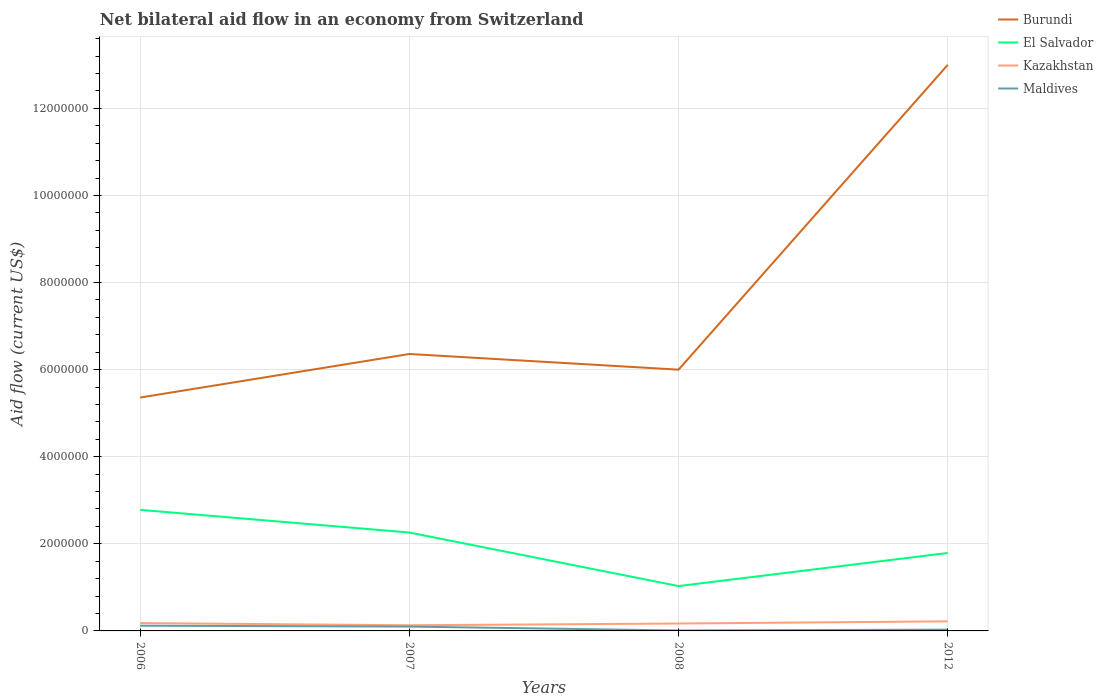How many different coloured lines are there?
Make the answer very short. 4. Does the line corresponding to Kazakhstan intersect with the line corresponding to El Salvador?
Keep it short and to the point. No. Across all years, what is the maximum net bilateral aid flow in El Salvador?
Ensure brevity in your answer.  1.03e+06. In which year was the net bilateral aid flow in Maldives maximum?
Your answer should be very brief. 2008. What is the total net bilateral aid flow in Maldives in the graph?
Offer a terse response. 2.00e+04. What is the difference between the highest and the second highest net bilateral aid flow in Burundi?
Provide a succinct answer. 7.64e+06. How many lines are there?
Make the answer very short. 4. What is the difference between two consecutive major ticks on the Y-axis?
Provide a short and direct response. 2.00e+06. Does the graph contain any zero values?
Your answer should be very brief. No. Where does the legend appear in the graph?
Your response must be concise. Top right. How many legend labels are there?
Offer a terse response. 4. How are the legend labels stacked?
Keep it short and to the point. Vertical. What is the title of the graph?
Give a very brief answer. Net bilateral aid flow in an economy from Switzerland. Does "Lower middle income" appear as one of the legend labels in the graph?
Your answer should be compact. No. What is the Aid flow (current US$) in Burundi in 2006?
Offer a terse response. 5.36e+06. What is the Aid flow (current US$) in El Salvador in 2006?
Give a very brief answer. 2.78e+06. What is the Aid flow (current US$) in Maldives in 2006?
Your response must be concise. 1.20e+05. What is the Aid flow (current US$) of Burundi in 2007?
Offer a terse response. 6.36e+06. What is the Aid flow (current US$) of El Salvador in 2007?
Offer a very short reply. 2.26e+06. What is the Aid flow (current US$) in Kazakhstan in 2007?
Keep it short and to the point. 1.30e+05. What is the Aid flow (current US$) of Maldives in 2007?
Your answer should be compact. 1.00e+05. What is the Aid flow (current US$) of Burundi in 2008?
Offer a very short reply. 6.00e+06. What is the Aid flow (current US$) in El Salvador in 2008?
Make the answer very short. 1.03e+06. What is the Aid flow (current US$) of Kazakhstan in 2008?
Provide a short and direct response. 1.70e+05. What is the Aid flow (current US$) in Burundi in 2012?
Ensure brevity in your answer.  1.30e+07. What is the Aid flow (current US$) of El Salvador in 2012?
Keep it short and to the point. 1.79e+06. What is the Aid flow (current US$) of Kazakhstan in 2012?
Your answer should be very brief. 2.20e+05. What is the Aid flow (current US$) of Maldives in 2012?
Provide a succinct answer. 3.00e+04. Across all years, what is the maximum Aid flow (current US$) of Burundi?
Ensure brevity in your answer.  1.30e+07. Across all years, what is the maximum Aid flow (current US$) of El Salvador?
Offer a very short reply. 2.78e+06. Across all years, what is the maximum Aid flow (current US$) in Kazakhstan?
Offer a terse response. 2.20e+05. Across all years, what is the minimum Aid flow (current US$) of Burundi?
Offer a terse response. 5.36e+06. Across all years, what is the minimum Aid flow (current US$) of El Salvador?
Make the answer very short. 1.03e+06. Across all years, what is the minimum Aid flow (current US$) of Kazakhstan?
Offer a terse response. 1.30e+05. Across all years, what is the minimum Aid flow (current US$) of Maldives?
Your answer should be very brief. 10000. What is the total Aid flow (current US$) of Burundi in the graph?
Make the answer very short. 3.07e+07. What is the total Aid flow (current US$) in El Salvador in the graph?
Keep it short and to the point. 7.86e+06. What is the total Aid flow (current US$) of Kazakhstan in the graph?
Your answer should be very brief. 7.00e+05. What is the difference between the Aid flow (current US$) in Burundi in 2006 and that in 2007?
Provide a short and direct response. -1.00e+06. What is the difference between the Aid flow (current US$) in El Salvador in 2006 and that in 2007?
Make the answer very short. 5.20e+05. What is the difference between the Aid flow (current US$) of Kazakhstan in 2006 and that in 2007?
Ensure brevity in your answer.  5.00e+04. What is the difference between the Aid flow (current US$) of Maldives in 2006 and that in 2007?
Keep it short and to the point. 2.00e+04. What is the difference between the Aid flow (current US$) of Burundi in 2006 and that in 2008?
Your answer should be very brief. -6.40e+05. What is the difference between the Aid flow (current US$) of El Salvador in 2006 and that in 2008?
Offer a very short reply. 1.75e+06. What is the difference between the Aid flow (current US$) in Kazakhstan in 2006 and that in 2008?
Your answer should be compact. 10000. What is the difference between the Aid flow (current US$) of Burundi in 2006 and that in 2012?
Offer a terse response. -7.64e+06. What is the difference between the Aid flow (current US$) in El Salvador in 2006 and that in 2012?
Your answer should be very brief. 9.90e+05. What is the difference between the Aid flow (current US$) in Kazakhstan in 2006 and that in 2012?
Keep it short and to the point. -4.00e+04. What is the difference between the Aid flow (current US$) of Burundi in 2007 and that in 2008?
Offer a terse response. 3.60e+05. What is the difference between the Aid flow (current US$) in El Salvador in 2007 and that in 2008?
Provide a succinct answer. 1.23e+06. What is the difference between the Aid flow (current US$) of Kazakhstan in 2007 and that in 2008?
Offer a terse response. -4.00e+04. What is the difference between the Aid flow (current US$) of Burundi in 2007 and that in 2012?
Keep it short and to the point. -6.64e+06. What is the difference between the Aid flow (current US$) of Maldives in 2007 and that in 2012?
Provide a succinct answer. 7.00e+04. What is the difference between the Aid flow (current US$) in Burundi in 2008 and that in 2012?
Offer a terse response. -7.00e+06. What is the difference between the Aid flow (current US$) in El Salvador in 2008 and that in 2012?
Your response must be concise. -7.60e+05. What is the difference between the Aid flow (current US$) of Kazakhstan in 2008 and that in 2012?
Your answer should be compact. -5.00e+04. What is the difference between the Aid flow (current US$) in Burundi in 2006 and the Aid flow (current US$) in El Salvador in 2007?
Make the answer very short. 3.10e+06. What is the difference between the Aid flow (current US$) in Burundi in 2006 and the Aid flow (current US$) in Kazakhstan in 2007?
Your answer should be very brief. 5.23e+06. What is the difference between the Aid flow (current US$) in Burundi in 2006 and the Aid flow (current US$) in Maldives in 2007?
Make the answer very short. 5.26e+06. What is the difference between the Aid flow (current US$) of El Salvador in 2006 and the Aid flow (current US$) of Kazakhstan in 2007?
Ensure brevity in your answer.  2.65e+06. What is the difference between the Aid flow (current US$) in El Salvador in 2006 and the Aid flow (current US$) in Maldives in 2007?
Your answer should be compact. 2.68e+06. What is the difference between the Aid flow (current US$) in Burundi in 2006 and the Aid flow (current US$) in El Salvador in 2008?
Your answer should be very brief. 4.33e+06. What is the difference between the Aid flow (current US$) in Burundi in 2006 and the Aid flow (current US$) in Kazakhstan in 2008?
Your answer should be compact. 5.19e+06. What is the difference between the Aid flow (current US$) of Burundi in 2006 and the Aid flow (current US$) of Maldives in 2008?
Your response must be concise. 5.35e+06. What is the difference between the Aid flow (current US$) of El Salvador in 2006 and the Aid flow (current US$) of Kazakhstan in 2008?
Your response must be concise. 2.61e+06. What is the difference between the Aid flow (current US$) in El Salvador in 2006 and the Aid flow (current US$) in Maldives in 2008?
Make the answer very short. 2.77e+06. What is the difference between the Aid flow (current US$) of Burundi in 2006 and the Aid flow (current US$) of El Salvador in 2012?
Provide a short and direct response. 3.57e+06. What is the difference between the Aid flow (current US$) in Burundi in 2006 and the Aid flow (current US$) in Kazakhstan in 2012?
Give a very brief answer. 5.14e+06. What is the difference between the Aid flow (current US$) in Burundi in 2006 and the Aid flow (current US$) in Maldives in 2012?
Provide a short and direct response. 5.33e+06. What is the difference between the Aid flow (current US$) of El Salvador in 2006 and the Aid flow (current US$) of Kazakhstan in 2012?
Your answer should be compact. 2.56e+06. What is the difference between the Aid flow (current US$) in El Salvador in 2006 and the Aid flow (current US$) in Maldives in 2012?
Give a very brief answer. 2.75e+06. What is the difference between the Aid flow (current US$) in Kazakhstan in 2006 and the Aid flow (current US$) in Maldives in 2012?
Your answer should be compact. 1.50e+05. What is the difference between the Aid flow (current US$) of Burundi in 2007 and the Aid flow (current US$) of El Salvador in 2008?
Offer a terse response. 5.33e+06. What is the difference between the Aid flow (current US$) in Burundi in 2007 and the Aid flow (current US$) in Kazakhstan in 2008?
Your answer should be very brief. 6.19e+06. What is the difference between the Aid flow (current US$) in Burundi in 2007 and the Aid flow (current US$) in Maldives in 2008?
Your response must be concise. 6.35e+06. What is the difference between the Aid flow (current US$) in El Salvador in 2007 and the Aid flow (current US$) in Kazakhstan in 2008?
Offer a very short reply. 2.09e+06. What is the difference between the Aid flow (current US$) in El Salvador in 2007 and the Aid flow (current US$) in Maldives in 2008?
Make the answer very short. 2.25e+06. What is the difference between the Aid flow (current US$) of Burundi in 2007 and the Aid flow (current US$) of El Salvador in 2012?
Give a very brief answer. 4.57e+06. What is the difference between the Aid flow (current US$) of Burundi in 2007 and the Aid flow (current US$) of Kazakhstan in 2012?
Provide a succinct answer. 6.14e+06. What is the difference between the Aid flow (current US$) of Burundi in 2007 and the Aid flow (current US$) of Maldives in 2012?
Make the answer very short. 6.33e+06. What is the difference between the Aid flow (current US$) of El Salvador in 2007 and the Aid flow (current US$) of Kazakhstan in 2012?
Provide a short and direct response. 2.04e+06. What is the difference between the Aid flow (current US$) of El Salvador in 2007 and the Aid flow (current US$) of Maldives in 2012?
Your answer should be very brief. 2.23e+06. What is the difference between the Aid flow (current US$) in Kazakhstan in 2007 and the Aid flow (current US$) in Maldives in 2012?
Provide a succinct answer. 1.00e+05. What is the difference between the Aid flow (current US$) of Burundi in 2008 and the Aid flow (current US$) of El Salvador in 2012?
Provide a short and direct response. 4.21e+06. What is the difference between the Aid flow (current US$) in Burundi in 2008 and the Aid flow (current US$) in Kazakhstan in 2012?
Make the answer very short. 5.78e+06. What is the difference between the Aid flow (current US$) in Burundi in 2008 and the Aid flow (current US$) in Maldives in 2012?
Offer a very short reply. 5.97e+06. What is the difference between the Aid flow (current US$) in El Salvador in 2008 and the Aid flow (current US$) in Kazakhstan in 2012?
Provide a succinct answer. 8.10e+05. What is the difference between the Aid flow (current US$) in Kazakhstan in 2008 and the Aid flow (current US$) in Maldives in 2012?
Your answer should be very brief. 1.40e+05. What is the average Aid flow (current US$) in Burundi per year?
Provide a short and direct response. 7.68e+06. What is the average Aid flow (current US$) in El Salvador per year?
Your answer should be very brief. 1.96e+06. What is the average Aid flow (current US$) of Kazakhstan per year?
Provide a succinct answer. 1.75e+05. What is the average Aid flow (current US$) in Maldives per year?
Your answer should be very brief. 6.50e+04. In the year 2006, what is the difference between the Aid flow (current US$) of Burundi and Aid flow (current US$) of El Salvador?
Offer a terse response. 2.58e+06. In the year 2006, what is the difference between the Aid flow (current US$) in Burundi and Aid flow (current US$) in Kazakhstan?
Offer a very short reply. 5.18e+06. In the year 2006, what is the difference between the Aid flow (current US$) of Burundi and Aid flow (current US$) of Maldives?
Your response must be concise. 5.24e+06. In the year 2006, what is the difference between the Aid flow (current US$) of El Salvador and Aid flow (current US$) of Kazakhstan?
Keep it short and to the point. 2.60e+06. In the year 2006, what is the difference between the Aid flow (current US$) of El Salvador and Aid flow (current US$) of Maldives?
Your answer should be compact. 2.66e+06. In the year 2006, what is the difference between the Aid flow (current US$) in Kazakhstan and Aid flow (current US$) in Maldives?
Keep it short and to the point. 6.00e+04. In the year 2007, what is the difference between the Aid flow (current US$) in Burundi and Aid flow (current US$) in El Salvador?
Keep it short and to the point. 4.10e+06. In the year 2007, what is the difference between the Aid flow (current US$) in Burundi and Aid flow (current US$) in Kazakhstan?
Your answer should be very brief. 6.23e+06. In the year 2007, what is the difference between the Aid flow (current US$) of Burundi and Aid flow (current US$) of Maldives?
Your answer should be compact. 6.26e+06. In the year 2007, what is the difference between the Aid flow (current US$) of El Salvador and Aid flow (current US$) of Kazakhstan?
Give a very brief answer. 2.13e+06. In the year 2007, what is the difference between the Aid flow (current US$) in El Salvador and Aid flow (current US$) in Maldives?
Provide a succinct answer. 2.16e+06. In the year 2008, what is the difference between the Aid flow (current US$) in Burundi and Aid flow (current US$) in El Salvador?
Your answer should be compact. 4.97e+06. In the year 2008, what is the difference between the Aid flow (current US$) in Burundi and Aid flow (current US$) in Kazakhstan?
Keep it short and to the point. 5.83e+06. In the year 2008, what is the difference between the Aid flow (current US$) in Burundi and Aid flow (current US$) in Maldives?
Offer a very short reply. 5.99e+06. In the year 2008, what is the difference between the Aid flow (current US$) of El Salvador and Aid flow (current US$) of Kazakhstan?
Provide a short and direct response. 8.60e+05. In the year 2008, what is the difference between the Aid flow (current US$) of El Salvador and Aid flow (current US$) of Maldives?
Offer a terse response. 1.02e+06. In the year 2008, what is the difference between the Aid flow (current US$) in Kazakhstan and Aid flow (current US$) in Maldives?
Give a very brief answer. 1.60e+05. In the year 2012, what is the difference between the Aid flow (current US$) in Burundi and Aid flow (current US$) in El Salvador?
Provide a succinct answer. 1.12e+07. In the year 2012, what is the difference between the Aid flow (current US$) of Burundi and Aid flow (current US$) of Kazakhstan?
Give a very brief answer. 1.28e+07. In the year 2012, what is the difference between the Aid flow (current US$) of Burundi and Aid flow (current US$) of Maldives?
Offer a very short reply. 1.30e+07. In the year 2012, what is the difference between the Aid flow (current US$) in El Salvador and Aid flow (current US$) in Kazakhstan?
Ensure brevity in your answer.  1.57e+06. In the year 2012, what is the difference between the Aid flow (current US$) of El Salvador and Aid flow (current US$) of Maldives?
Keep it short and to the point. 1.76e+06. What is the ratio of the Aid flow (current US$) of Burundi in 2006 to that in 2007?
Provide a short and direct response. 0.84. What is the ratio of the Aid flow (current US$) of El Salvador in 2006 to that in 2007?
Provide a short and direct response. 1.23. What is the ratio of the Aid flow (current US$) in Kazakhstan in 2006 to that in 2007?
Your response must be concise. 1.38. What is the ratio of the Aid flow (current US$) in Burundi in 2006 to that in 2008?
Your answer should be compact. 0.89. What is the ratio of the Aid flow (current US$) in El Salvador in 2006 to that in 2008?
Your answer should be very brief. 2.7. What is the ratio of the Aid flow (current US$) in Kazakhstan in 2006 to that in 2008?
Give a very brief answer. 1.06. What is the ratio of the Aid flow (current US$) of Maldives in 2006 to that in 2008?
Make the answer very short. 12. What is the ratio of the Aid flow (current US$) of Burundi in 2006 to that in 2012?
Offer a terse response. 0.41. What is the ratio of the Aid flow (current US$) of El Salvador in 2006 to that in 2012?
Your answer should be very brief. 1.55. What is the ratio of the Aid flow (current US$) of Kazakhstan in 2006 to that in 2012?
Your answer should be very brief. 0.82. What is the ratio of the Aid flow (current US$) in Maldives in 2006 to that in 2012?
Give a very brief answer. 4. What is the ratio of the Aid flow (current US$) of Burundi in 2007 to that in 2008?
Offer a very short reply. 1.06. What is the ratio of the Aid flow (current US$) of El Salvador in 2007 to that in 2008?
Ensure brevity in your answer.  2.19. What is the ratio of the Aid flow (current US$) in Kazakhstan in 2007 to that in 2008?
Ensure brevity in your answer.  0.76. What is the ratio of the Aid flow (current US$) in Maldives in 2007 to that in 2008?
Keep it short and to the point. 10. What is the ratio of the Aid flow (current US$) in Burundi in 2007 to that in 2012?
Ensure brevity in your answer.  0.49. What is the ratio of the Aid flow (current US$) in El Salvador in 2007 to that in 2012?
Your response must be concise. 1.26. What is the ratio of the Aid flow (current US$) of Kazakhstan in 2007 to that in 2012?
Ensure brevity in your answer.  0.59. What is the ratio of the Aid flow (current US$) in Burundi in 2008 to that in 2012?
Offer a terse response. 0.46. What is the ratio of the Aid flow (current US$) in El Salvador in 2008 to that in 2012?
Make the answer very short. 0.58. What is the ratio of the Aid flow (current US$) in Kazakhstan in 2008 to that in 2012?
Offer a terse response. 0.77. What is the difference between the highest and the second highest Aid flow (current US$) in Burundi?
Offer a very short reply. 6.64e+06. What is the difference between the highest and the second highest Aid flow (current US$) of El Salvador?
Your answer should be very brief. 5.20e+05. What is the difference between the highest and the lowest Aid flow (current US$) in Burundi?
Provide a succinct answer. 7.64e+06. What is the difference between the highest and the lowest Aid flow (current US$) of El Salvador?
Your answer should be compact. 1.75e+06. What is the difference between the highest and the lowest Aid flow (current US$) of Kazakhstan?
Offer a very short reply. 9.00e+04. What is the difference between the highest and the lowest Aid flow (current US$) of Maldives?
Your response must be concise. 1.10e+05. 